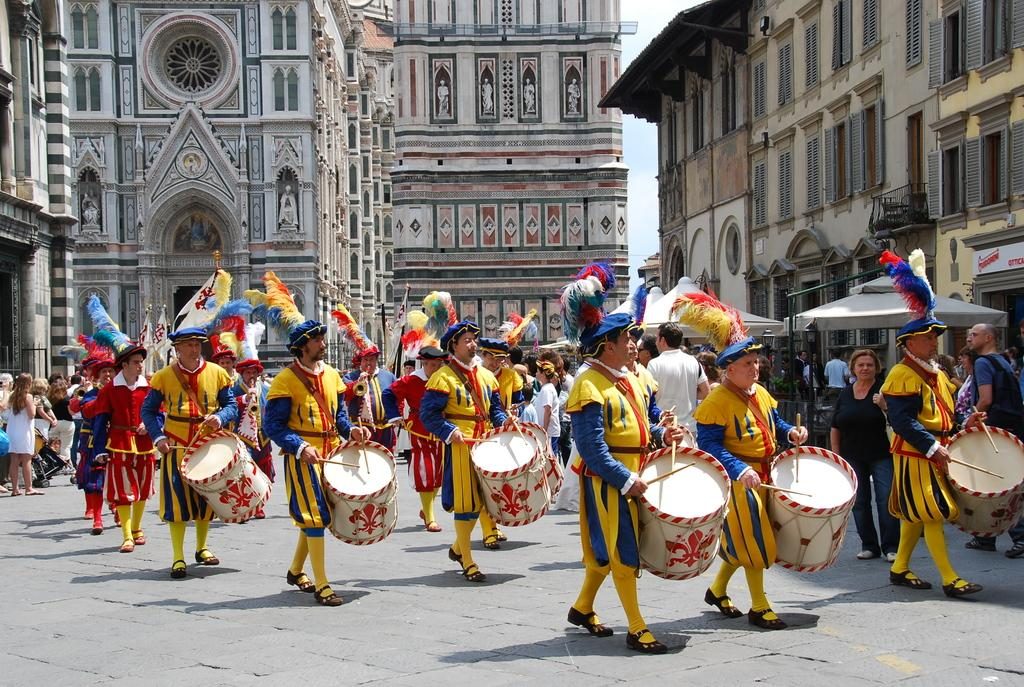What are the people in the image doing? There are many persons playing drums in the image. What are the people wearing? All the persons are wearing yellow dress. What can be seen in the background of the image? There are buildings in the background of the image. What is located to the right of the image? There are windows and a tent to the right of the image. What direction are the drums being played in the image? The direction in which the drums are being played cannot be determined from the image, as it only shows the people playing drums and their yellow dress. 